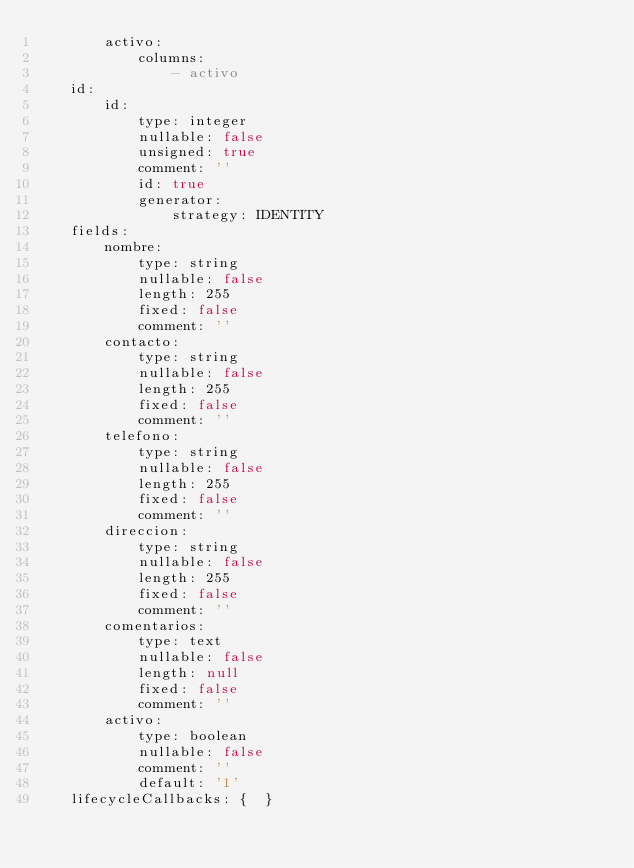Convert code to text. <code><loc_0><loc_0><loc_500><loc_500><_YAML_>        activo:
            columns:
                - activo
    id:
        id:
            type: integer
            nullable: false
            unsigned: true
            comment: ''
            id: true
            generator:
                strategy: IDENTITY
    fields:
        nombre:
            type: string
            nullable: false
            length: 255
            fixed: false
            comment: ''
        contacto:
            type: string
            nullable: false
            length: 255
            fixed: false
            comment: ''
        telefono:
            type: string
            nullable: false
            length: 255
            fixed: false
            comment: ''
        direccion:
            type: string
            nullable: false
            length: 255
            fixed: false
            comment: ''
        comentarios:
            type: text
            nullable: false
            length: null
            fixed: false
            comment: ''
        activo:
            type: boolean
            nullable: false
            comment: ''
            default: '1'
    lifecycleCallbacks: {  }
</code> 